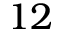<formula> <loc_0><loc_0><loc_500><loc_500>1 2</formula> 